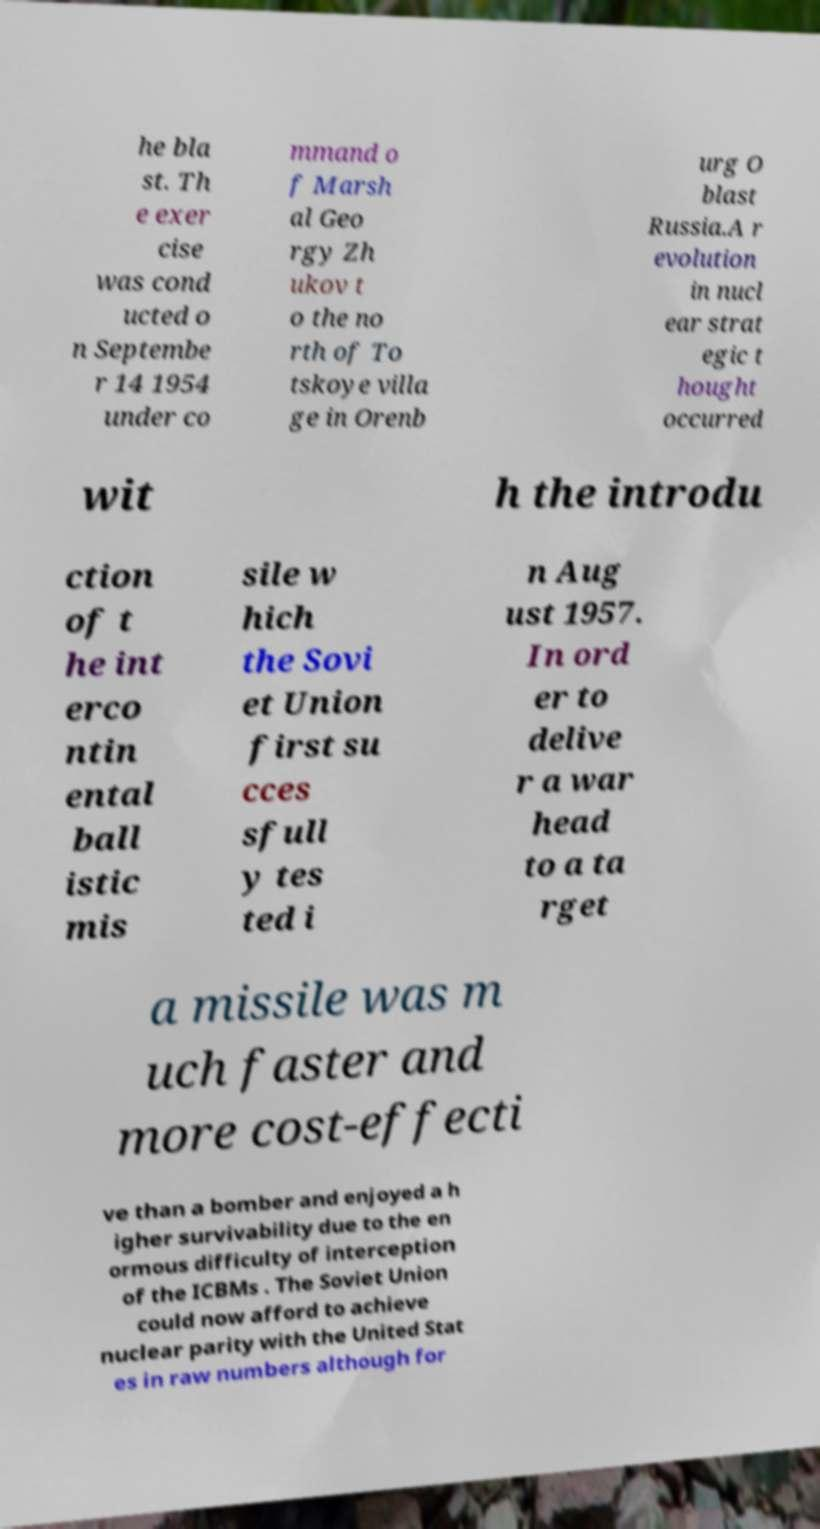Could you extract and type out the text from this image? he bla st. Th e exer cise was cond ucted o n Septembe r 14 1954 under co mmand o f Marsh al Geo rgy Zh ukov t o the no rth of To tskoye villa ge in Orenb urg O blast Russia.A r evolution in nucl ear strat egic t hought occurred wit h the introdu ction of t he int erco ntin ental ball istic mis sile w hich the Sovi et Union first su cces sfull y tes ted i n Aug ust 1957. In ord er to delive r a war head to a ta rget a missile was m uch faster and more cost-effecti ve than a bomber and enjoyed a h igher survivability due to the en ormous difficulty of interception of the ICBMs . The Soviet Union could now afford to achieve nuclear parity with the United Stat es in raw numbers although for 